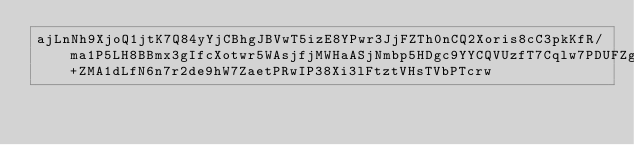Convert code to text. <code><loc_0><loc_0><loc_500><loc_500><_SML_>ajLnNh9XjoQ1jtK7Q84yYjCBhgJBVwT5izE8YPwr3JjFZTh0nCQ2Xoris8cC3pkKfR/ma1P5LH8BBmx3gIfcXotwr5WAsjfjMWHaASjNmbp5HDgc9YYCQVUzfT7Cqlw7PDUFZgFyLZfA25dvZl4Pfpsp4q+ZMA1dLfN6n7r2de9hW7ZaetPRwIP38Xi3lFtztVHsTVbPTcrw</code> 